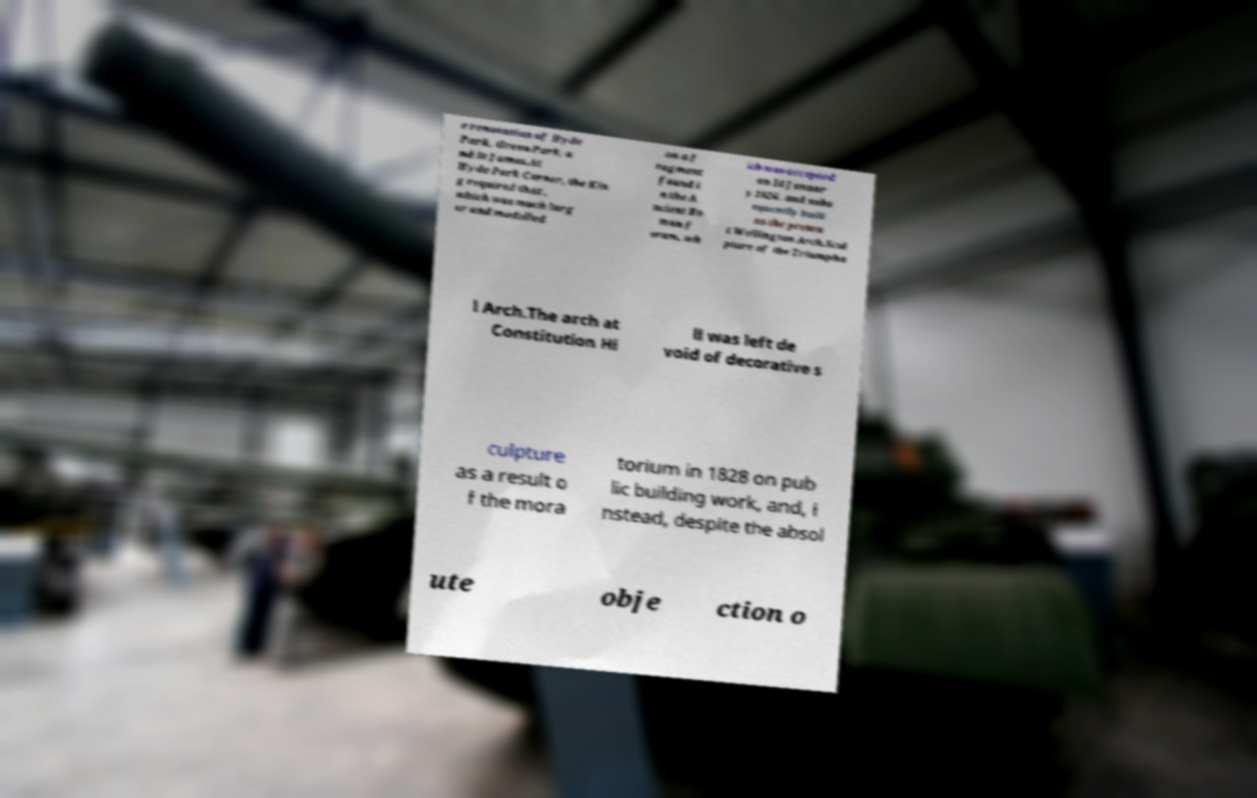Please read and relay the text visible in this image. What does it say? e renovation of Hyde Park, Green Park, a nd St James.At Hyde Park Corner, the Kin g required that , which was much larg er and modelled on a f ragment found i n the A ncient Ro man f orum, wh ich was accepted on 14 Januar y 1826, and subs equently built as the presen t Wellington Arch.Scul pture of the Triumpha l Arch.The arch at Constitution Hi ll was left de void of decorative s culpture as a result o f the mora torium in 1828 on pub lic building work, and, i nstead, despite the absol ute obje ction o 